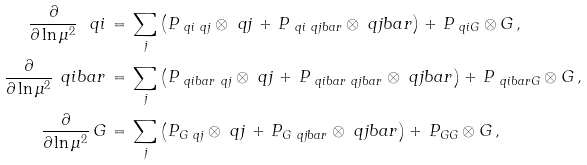Convert formula to latex. <formula><loc_0><loc_0><loc_500><loc_500>\frac { \partial } { \partial \ln \mu ^ { 2 } } \, \ q i \, & = \, \sum _ { j } \left ( P _ { \ q i \ q j } \otimes \ q j \, + \, P _ { \ q i \ q j b a r } \otimes \ q j b a r \right ) + \, P _ { \ q i G } \otimes G \, , \\ \frac { \partial } { \partial \ln \mu ^ { 2 } } \, \ q i b a r \, & = \, \sum _ { j } \left ( P _ { \ q i b a r \ q j } \otimes \ q j \, + \, P _ { \ q i b a r \ q j b a r } \otimes \ q j b a r \right ) + \, P _ { \ q i b a r G } \otimes G \, , \\ \frac { \partial } { \partial \ln \mu ^ { 2 } } \, G \, & = \, \sum _ { j } \left ( P _ { G \ q j } \otimes \ q j \, + \, P _ { G \ q j b a r } \otimes \ q j b a r \right ) + \, P _ { G G } \otimes G \, ,</formula> 